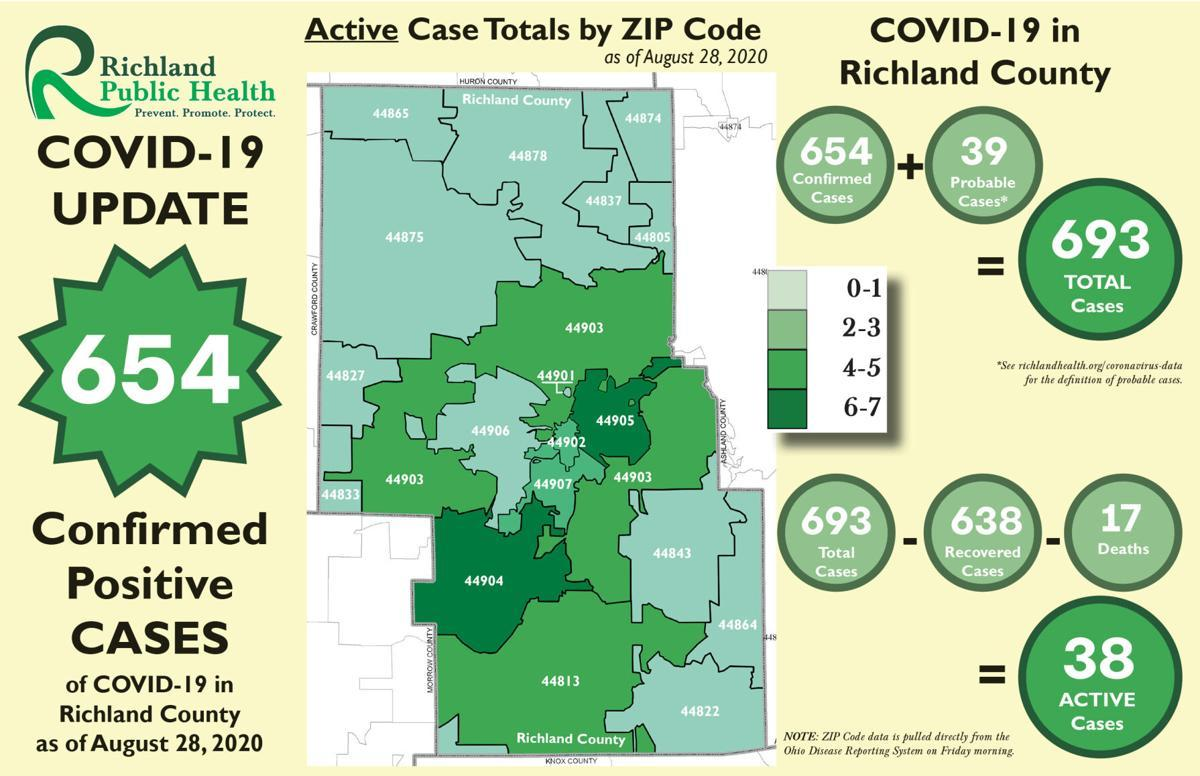Indicate a few pertinent items in this graphic. As of August 28, 2020, a total of 638 cases of COVID-19 that were recovered in Richland county had been reported. As of August 28, 2020, the reported number of COVID-19 deaths in Richland county is 17. As of August 28, 2020, there were 38 active COVID-19 cases reported in Richland county. As of August 28, 2020, the reported total number of COVID-19 cases in Richland county is 693. As of August 28, 2020, there were 654 confirmed positive cases of COVID-19 reported in Richland County. 